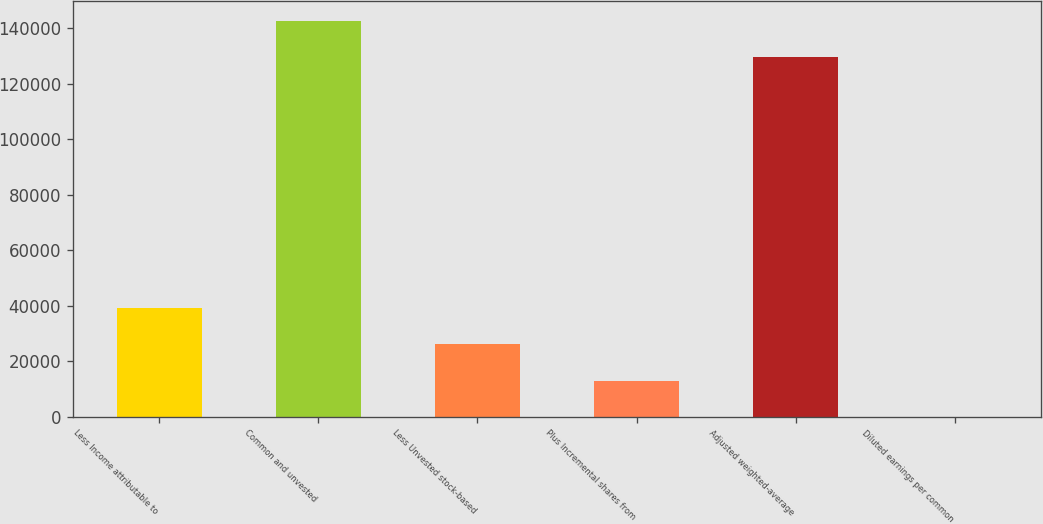<chart> <loc_0><loc_0><loc_500><loc_500><bar_chart><fcel>Less Income attributable to<fcel>Common and unvested<fcel>Less Unvested stock-based<fcel>Plus Incremental shares from<fcel>Adjusted weighted-average<fcel>Diluted earnings per common<nl><fcel>39111.9<fcel>142638<fcel>26077.4<fcel>13042.8<fcel>129603<fcel>8.2<nl></chart> 